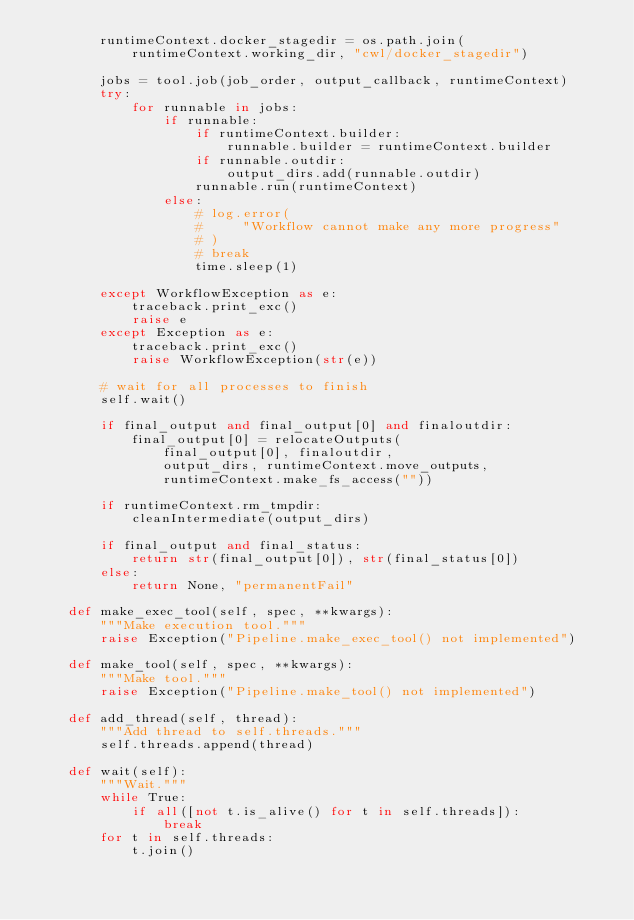Convert code to text. <code><loc_0><loc_0><loc_500><loc_500><_Python_>        runtimeContext.docker_stagedir = os.path.join(
            runtimeContext.working_dir, "cwl/docker_stagedir")

        jobs = tool.job(job_order, output_callback, runtimeContext)
        try:
            for runnable in jobs:
                if runnable:
                    if runtimeContext.builder:
                        runnable.builder = runtimeContext.builder
                    if runnable.outdir:
                        output_dirs.add(runnable.outdir)
                    runnable.run(runtimeContext)
                else:
                    # log.error(
                    #     "Workflow cannot make any more progress"
                    # )
                    # break
                    time.sleep(1)

        except WorkflowException as e:
            traceback.print_exc()
            raise e
        except Exception as e:
            traceback.print_exc()
            raise WorkflowException(str(e))

        # wait for all processes to finish
        self.wait()

        if final_output and final_output[0] and finaloutdir:
            final_output[0] = relocateOutputs(
                final_output[0], finaloutdir,
                output_dirs, runtimeContext.move_outputs,
                runtimeContext.make_fs_access(""))

        if runtimeContext.rm_tmpdir:
            cleanIntermediate(output_dirs)

        if final_output and final_status:
            return str(final_output[0]), str(final_status[0])
        else:
            return None, "permanentFail"

    def make_exec_tool(self, spec, **kwargs):
        """Make execution tool."""
        raise Exception("Pipeline.make_exec_tool() not implemented")

    def make_tool(self, spec, **kwargs):
        """Make tool."""
        raise Exception("Pipeline.make_tool() not implemented")

    def add_thread(self, thread):
        """Add thread to self.threads."""
        self.threads.append(thread)

    def wait(self):
        """Wait."""
        while True:
            if all([not t.is_alive() for t in self.threads]):
                break
        for t in self.threads:
            t.join()
</code> 